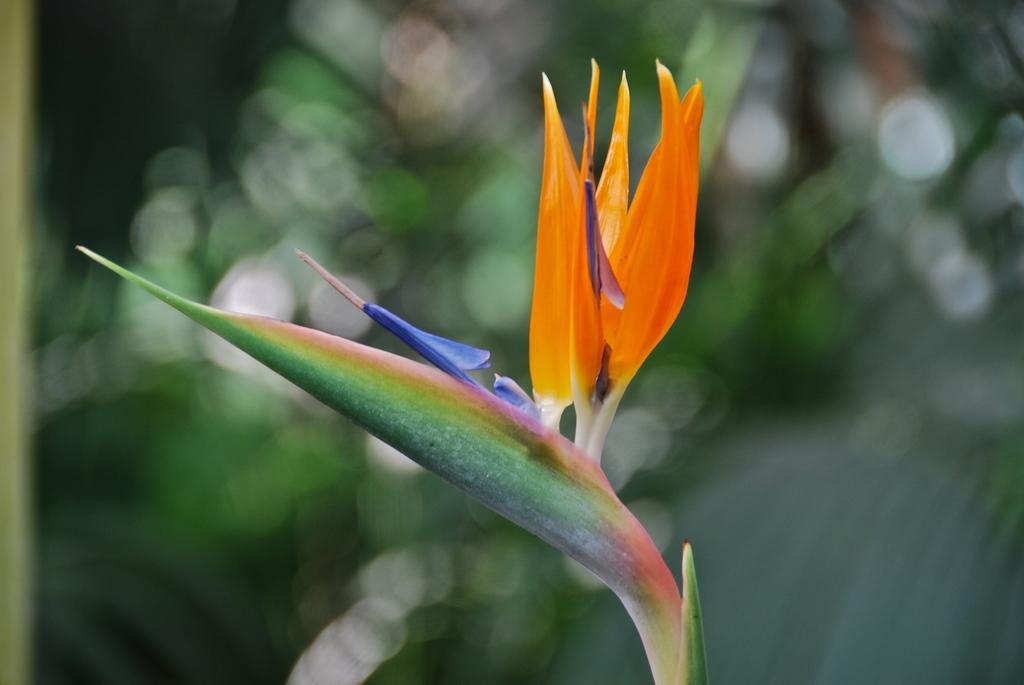Can you describe this image briefly? There is a plant in the foreground area of the image. 